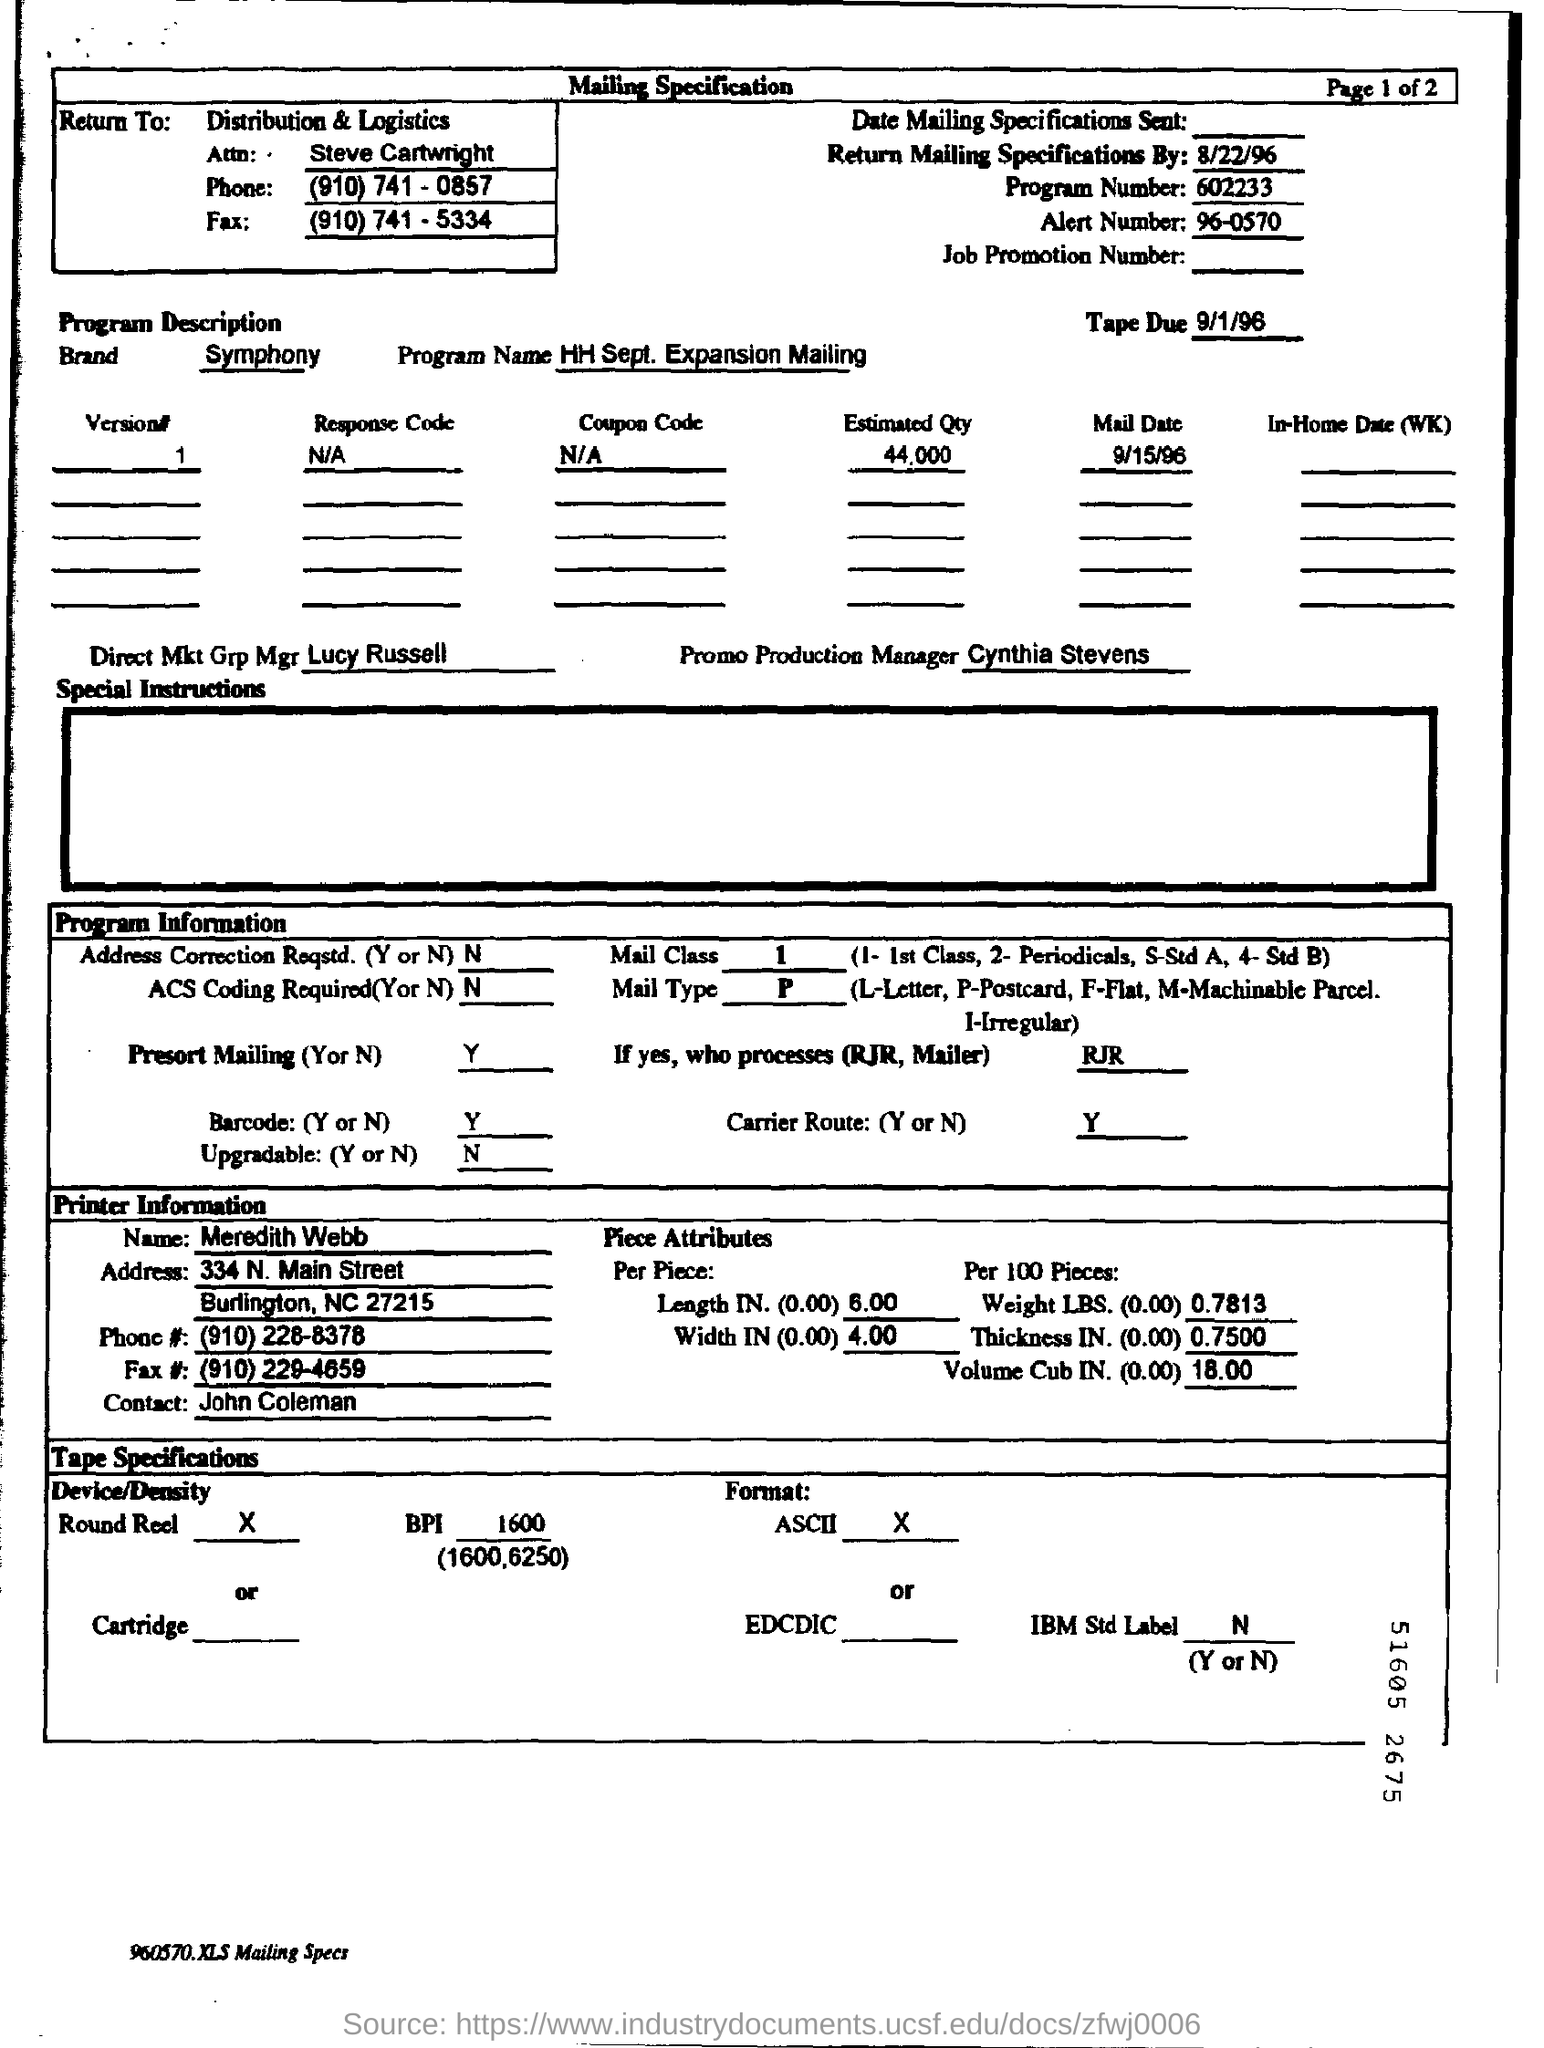Mention a couple of crucial points in this snapshot. The estimated quantity, as per the provided document, is 44,000. The brand mentioned in this document is Symphony. The Direct Mkt Grp Mgr is Lucy Russell. The alert number mentioned is 96-0570. The tape is due on September 1, 1996. 